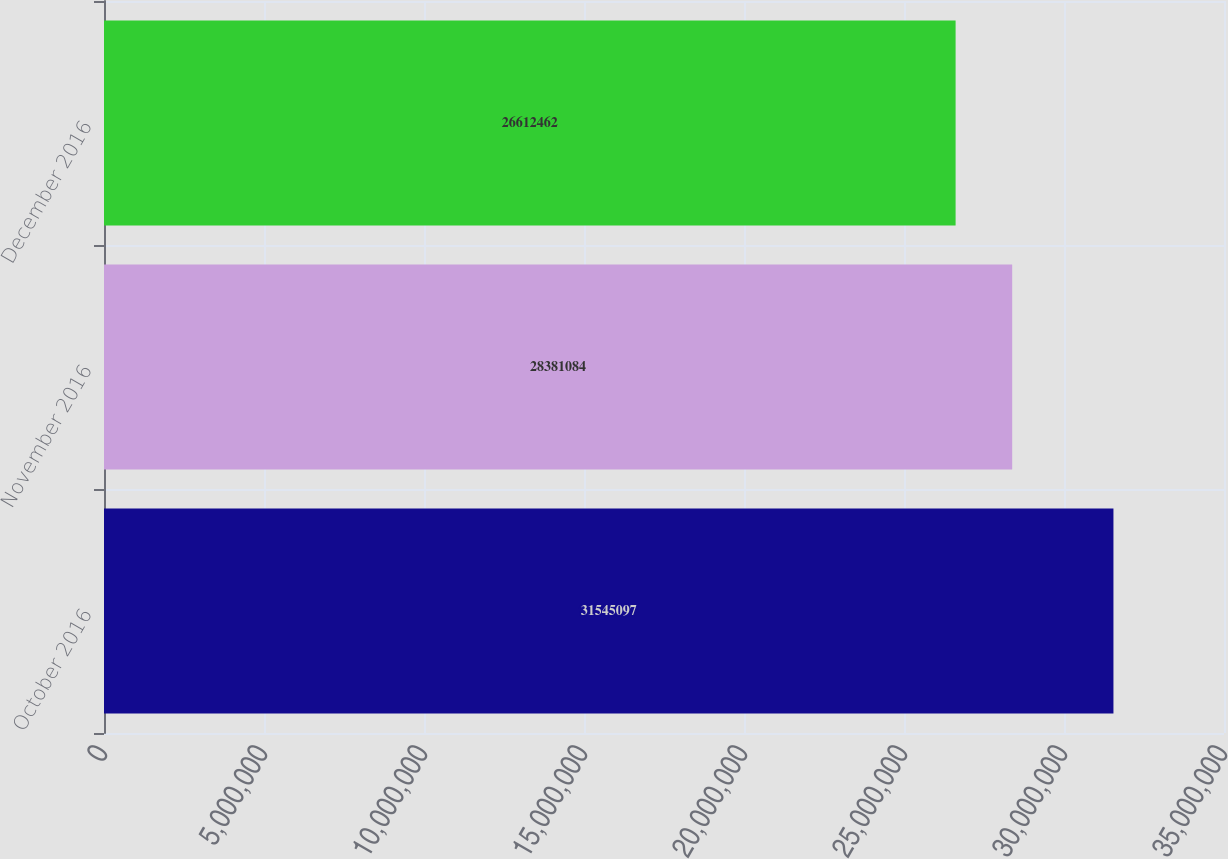Convert chart. <chart><loc_0><loc_0><loc_500><loc_500><bar_chart><fcel>October 2016<fcel>November 2016<fcel>December 2016<nl><fcel>3.15451e+07<fcel>2.83811e+07<fcel>2.66125e+07<nl></chart> 